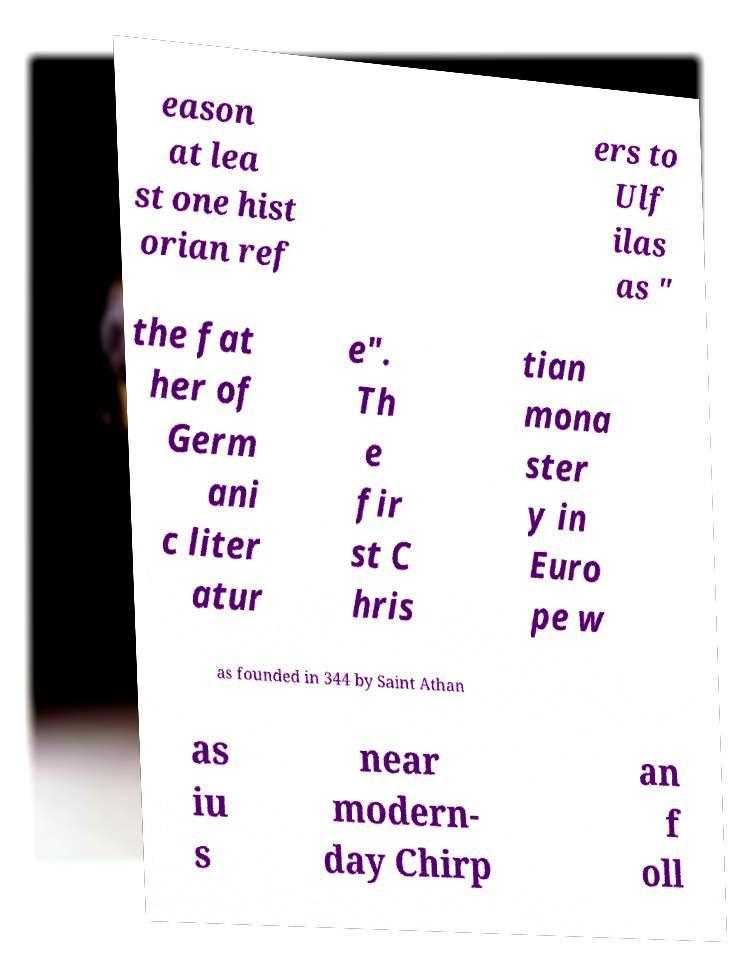Can you accurately transcribe the text from the provided image for me? eason at lea st one hist orian ref ers to Ulf ilas as " the fat her of Germ ani c liter atur e". Th e fir st C hris tian mona ster y in Euro pe w as founded in 344 by Saint Athan as iu s near modern- day Chirp an f oll 